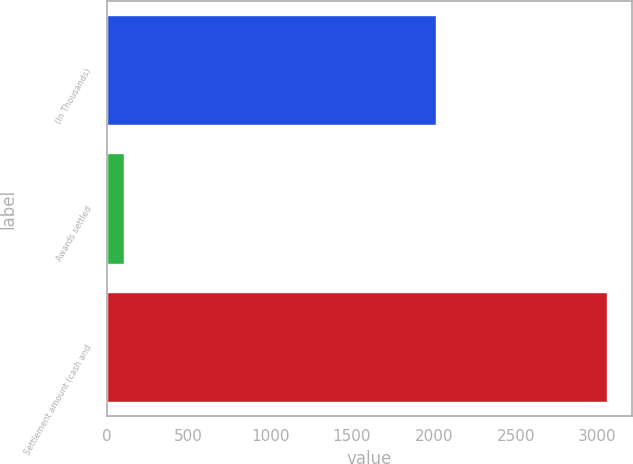Convert chart to OTSL. <chart><loc_0><loc_0><loc_500><loc_500><bar_chart><fcel>(In Thousands)<fcel>Awards settled<fcel>Settlement amount (cash and<nl><fcel>2013<fcel>108<fcel>3057<nl></chart> 